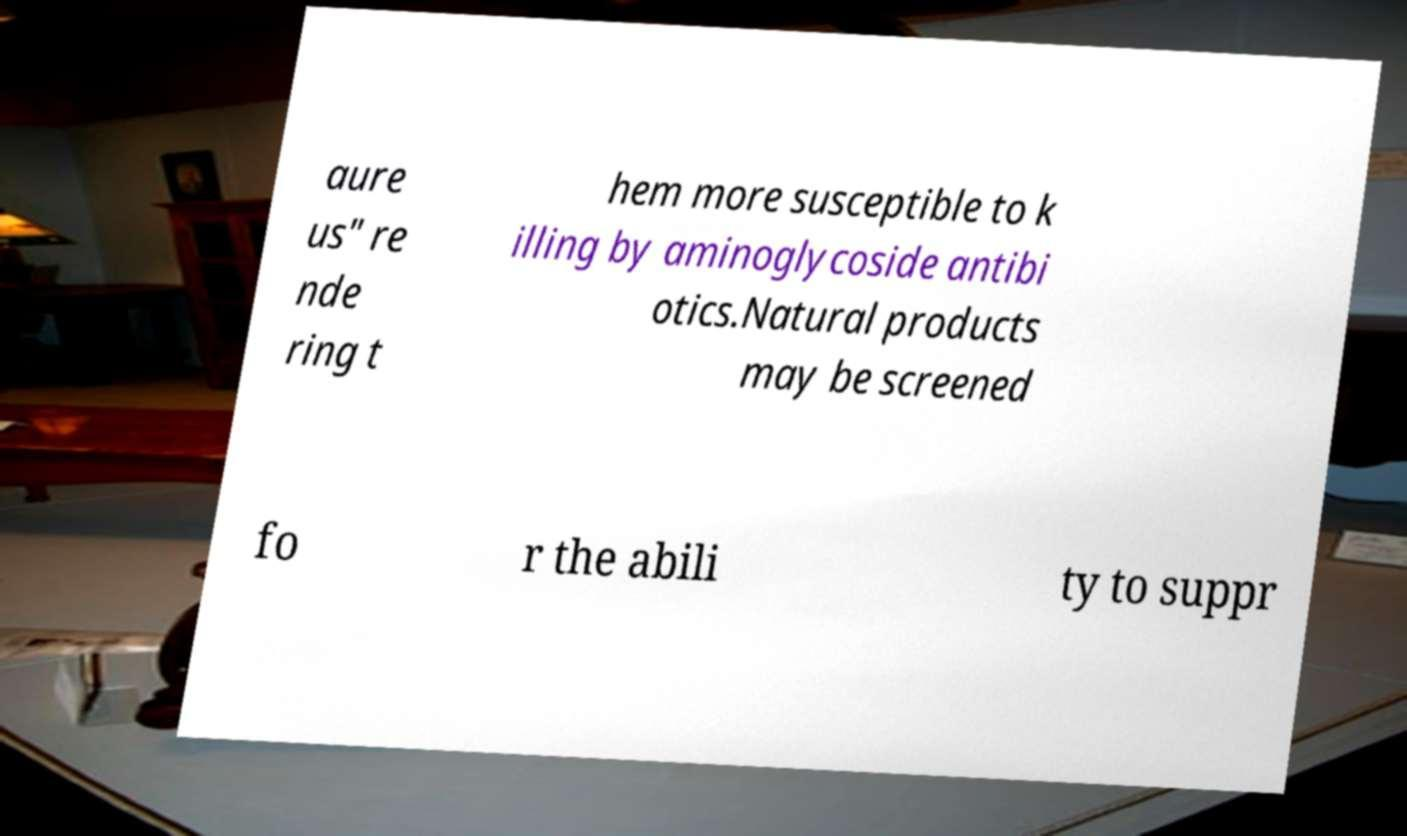I need the written content from this picture converted into text. Can you do that? aure us" re nde ring t hem more susceptible to k illing by aminoglycoside antibi otics.Natural products may be screened fo r the abili ty to suppr 